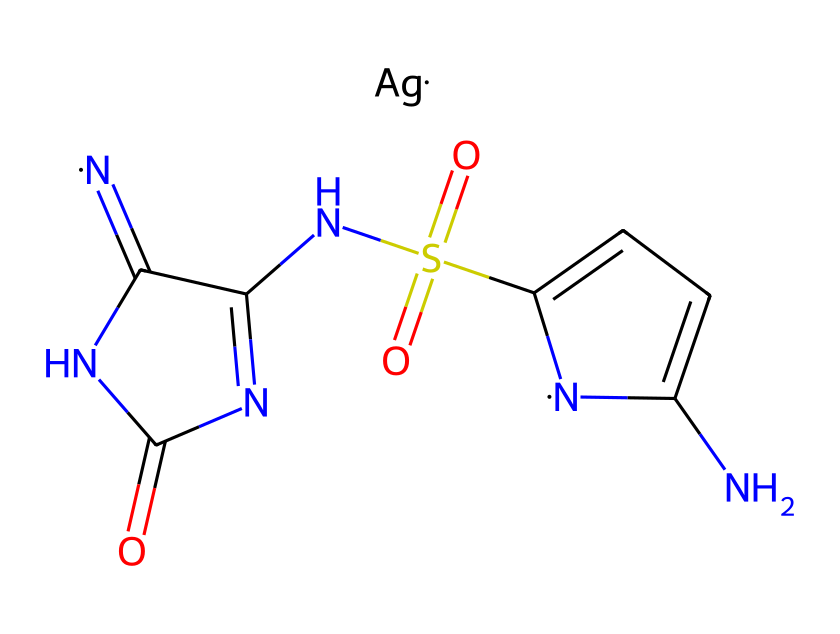How many nitrogen atoms are present in silver sulfadiazine? By examining the SMILES representation, we can count the number of nitrogen (N) symbols. There are three nitrogen atoms represented in the structure.
Answer: three What functional group is represented by S(=O)(=O)? The S(=O)(=O) notation indicates a sulfonamide group, which is characterized by a sulfur atom bonded to two oxygen atoms with double bonds, typical for sulfonamide pharmaceuticals.
Answer: sulfonamide What is the oxidation state of silver in silver sulfadiazine? The silver ion (Ag) is usually in the +1 oxidation state, as it is represented in the SMILES without any adjustments signifying a different charge.
Answer: +1 What type of bond connects the nitrogen atoms to the aromatic ring? The nitrogen atoms in the aromatic ring are connected by aromatic carbon-carbon bonds, which are characterized by partial double bond character due to resonance in the ring.
Answer: aromatic bonds How many total atoms are in silver sulfadiazine? Counting the atoms in the SMILES representation: there are 10 carbon (C), 3 nitrogen (N), 4 hydrogen (H), 1 silver (Ag), 1 sulfur (S), and 4 oxygen (O) atoms. Adding these gives a total of 19 atoms.
Answer: 19 What is the significance of silver in this compound? Silver acts as an antimicrobial agent, contributing to the effectiveness of the compound in preventing infection in burn wounds through its bactericidal properties.
Answer: antimicrobial agent Which part of the chemical structure indicates its antimicrobial activity? The sulfonamide part (S(=O)(=O)NC) is responsible for the antimicrobial activity, as sulfonamides are known to inhibit bacterial growth through competitive inhibition of bacterial enzymes.
Answer: sulfonamide 